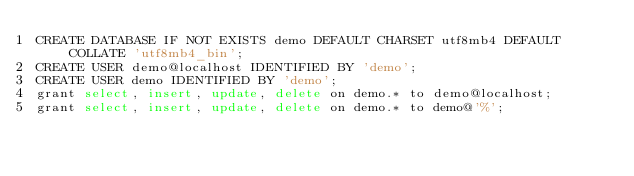Convert code to text. <code><loc_0><loc_0><loc_500><loc_500><_SQL_>CREATE DATABASE IF NOT EXISTS demo DEFAULT CHARSET utf8mb4 DEFAULT COLLATE 'utf8mb4_bin';
CREATE USER demo@localhost IDENTIFIED BY 'demo';
CREATE USER demo IDENTIFIED BY 'demo';
grant select, insert, update, delete on demo.* to demo@localhost;
grant select, insert, update, delete on demo.* to demo@'%';
</code> 